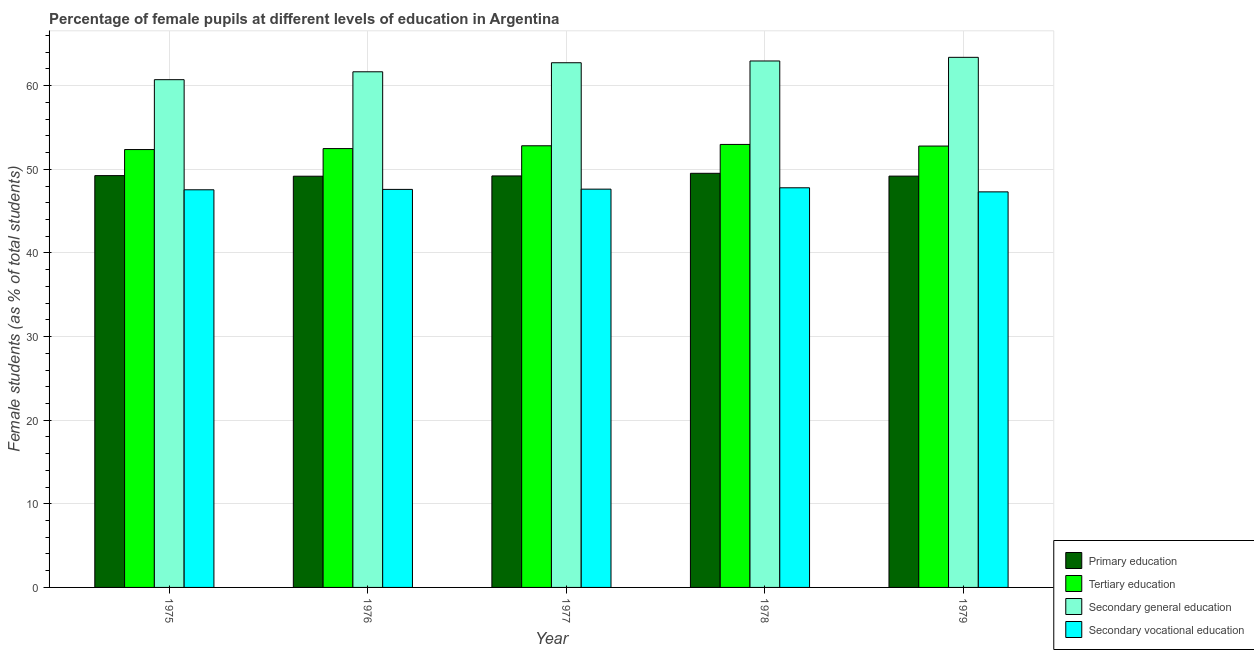Are the number of bars on each tick of the X-axis equal?
Offer a very short reply. Yes. How many bars are there on the 1st tick from the left?
Provide a succinct answer. 4. How many bars are there on the 5th tick from the right?
Ensure brevity in your answer.  4. What is the label of the 5th group of bars from the left?
Give a very brief answer. 1979. In how many cases, is the number of bars for a given year not equal to the number of legend labels?
Your response must be concise. 0. What is the percentage of female students in tertiary education in 1977?
Offer a terse response. 52.82. Across all years, what is the maximum percentage of female students in primary education?
Provide a succinct answer. 49.52. Across all years, what is the minimum percentage of female students in tertiary education?
Your answer should be very brief. 52.36. In which year was the percentage of female students in secondary vocational education maximum?
Ensure brevity in your answer.  1978. In which year was the percentage of female students in secondary vocational education minimum?
Your response must be concise. 1979. What is the total percentage of female students in secondary education in the graph?
Your answer should be compact. 311.48. What is the difference between the percentage of female students in secondary education in 1976 and that in 1978?
Give a very brief answer. -1.29. What is the difference between the percentage of female students in secondary vocational education in 1979 and the percentage of female students in primary education in 1975?
Offer a very short reply. -0.25. What is the average percentage of female students in primary education per year?
Make the answer very short. 49.27. In how many years, is the percentage of female students in primary education greater than 16 %?
Provide a short and direct response. 5. What is the ratio of the percentage of female students in primary education in 1975 to that in 1976?
Provide a short and direct response. 1. What is the difference between the highest and the second highest percentage of female students in secondary vocational education?
Provide a succinct answer. 0.16. What is the difference between the highest and the lowest percentage of female students in tertiary education?
Your answer should be compact. 0.61. In how many years, is the percentage of female students in secondary vocational education greater than the average percentage of female students in secondary vocational education taken over all years?
Give a very brief answer. 3. Is it the case that in every year, the sum of the percentage of female students in secondary education and percentage of female students in primary education is greater than the sum of percentage of female students in tertiary education and percentage of female students in secondary vocational education?
Ensure brevity in your answer.  Yes. What does the 2nd bar from the left in 1977 represents?
Provide a succinct answer. Tertiary education. What does the 1st bar from the right in 1976 represents?
Give a very brief answer. Secondary vocational education. How many bars are there?
Offer a terse response. 20. Are all the bars in the graph horizontal?
Your answer should be compact. No. How many years are there in the graph?
Offer a terse response. 5. Does the graph contain any zero values?
Offer a very short reply. No. Where does the legend appear in the graph?
Offer a terse response. Bottom right. How are the legend labels stacked?
Make the answer very short. Vertical. What is the title of the graph?
Offer a terse response. Percentage of female pupils at different levels of education in Argentina. Does "Quality of public administration" appear as one of the legend labels in the graph?
Your answer should be compact. No. What is the label or title of the Y-axis?
Keep it short and to the point. Female students (as % of total students). What is the Female students (as % of total students) in Primary education in 1975?
Offer a very short reply. 49.25. What is the Female students (as % of total students) in Tertiary education in 1975?
Offer a very short reply. 52.36. What is the Female students (as % of total students) in Secondary general education in 1975?
Your response must be concise. 60.72. What is the Female students (as % of total students) in Secondary vocational education in 1975?
Provide a short and direct response. 47.55. What is the Female students (as % of total students) of Primary education in 1976?
Your response must be concise. 49.18. What is the Female students (as % of total students) of Tertiary education in 1976?
Give a very brief answer. 52.48. What is the Female students (as % of total students) of Secondary general education in 1976?
Provide a short and direct response. 61.66. What is the Female students (as % of total students) in Secondary vocational education in 1976?
Provide a succinct answer. 47.6. What is the Female students (as % of total students) in Primary education in 1977?
Give a very brief answer. 49.21. What is the Female students (as % of total students) in Tertiary education in 1977?
Keep it short and to the point. 52.82. What is the Female students (as % of total students) of Secondary general education in 1977?
Offer a very short reply. 62.75. What is the Female students (as % of total students) in Secondary vocational education in 1977?
Make the answer very short. 47.63. What is the Female students (as % of total students) of Primary education in 1978?
Your answer should be compact. 49.52. What is the Female students (as % of total students) in Tertiary education in 1978?
Ensure brevity in your answer.  52.98. What is the Female students (as % of total students) in Secondary general education in 1978?
Your answer should be very brief. 62.96. What is the Female students (as % of total students) of Secondary vocational education in 1978?
Offer a very short reply. 47.79. What is the Female students (as % of total students) of Primary education in 1979?
Provide a short and direct response. 49.19. What is the Female students (as % of total students) of Tertiary education in 1979?
Your response must be concise. 52.78. What is the Female students (as % of total students) of Secondary general education in 1979?
Offer a very short reply. 63.39. What is the Female students (as % of total students) in Secondary vocational education in 1979?
Your answer should be compact. 47.3. Across all years, what is the maximum Female students (as % of total students) of Primary education?
Keep it short and to the point. 49.52. Across all years, what is the maximum Female students (as % of total students) in Tertiary education?
Keep it short and to the point. 52.98. Across all years, what is the maximum Female students (as % of total students) in Secondary general education?
Provide a succinct answer. 63.39. Across all years, what is the maximum Female students (as % of total students) of Secondary vocational education?
Provide a succinct answer. 47.79. Across all years, what is the minimum Female students (as % of total students) in Primary education?
Give a very brief answer. 49.18. Across all years, what is the minimum Female students (as % of total students) in Tertiary education?
Your response must be concise. 52.36. Across all years, what is the minimum Female students (as % of total students) in Secondary general education?
Your answer should be compact. 60.72. Across all years, what is the minimum Female students (as % of total students) of Secondary vocational education?
Your answer should be very brief. 47.3. What is the total Female students (as % of total students) in Primary education in the graph?
Provide a short and direct response. 246.34. What is the total Female students (as % of total students) in Tertiary education in the graph?
Ensure brevity in your answer.  263.42. What is the total Female students (as % of total students) of Secondary general education in the graph?
Provide a short and direct response. 311.48. What is the total Female students (as % of total students) of Secondary vocational education in the graph?
Make the answer very short. 237.88. What is the difference between the Female students (as % of total students) of Primary education in 1975 and that in 1976?
Offer a terse response. 0.07. What is the difference between the Female students (as % of total students) in Tertiary education in 1975 and that in 1976?
Keep it short and to the point. -0.12. What is the difference between the Female students (as % of total students) in Secondary general education in 1975 and that in 1976?
Your answer should be very brief. -0.94. What is the difference between the Female students (as % of total students) of Secondary vocational education in 1975 and that in 1976?
Make the answer very short. -0.05. What is the difference between the Female students (as % of total students) of Primary education in 1975 and that in 1977?
Ensure brevity in your answer.  0.04. What is the difference between the Female students (as % of total students) in Tertiary education in 1975 and that in 1977?
Offer a very short reply. -0.45. What is the difference between the Female students (as % of total students) in Secondary general education in 1975 and that in 1977?
Your response must be concise. -2.03. What is the difference between the Female students (as % of total students) in Secondary vocational education in 1975 and that in 1977?
Ensure brevity in your answer.  -0.08. What is the difference between the Female students (as % of total students) of Primary education in 1975 and that in 1978?
Ensure brevity in your answer.  -0.28. What is the difference between the Female students (as % of total students) of Tertiary education in 1975 and that in 1978?
Your answer should be very brief. -0.61. What is the difference between the Female students (as % of total students) in Secondary general education in 1975 and that in 1978?
Keep it short and to the point. -2.24. What is the difference between the Female students (as % of total students) in Secondary vocational education in 1975 and that in 1978?
Make the answer very short. -0.24. What is the difference between the Female students (as % of total students) in Primary education in 1975 and that in 1979?
Your answer should be compact. 0.06. What is the difference between the Female students (as % of total students) in Tertiary education in 1975 and that in 1979?
Offer a terse response. -0.42. What is the difference between the Female students (as % of total students) in Secondary general education in 1975 and that in 1979?
Offer a terse response. -2.67. What is the difference between the Female students (as % of total students) of Secondary vocational education in 1975 and that in 1979?
Your answer should be very brief. 0.25. What is the difference between the Female students (as % of total students) in Primary education in 1976 and that in 1977?
Offer a very short reply. -0.03. What is the difference between the Female students (as % of total students) of Tertiary education in 1976 and that in 1977?
Provide a succinct answer. -0.33. What is the difference between the Female students (as % of total students) in Secondary general education in 1976 and that in 1977?
Keep it short and to the point. -1.08. What is the difference between the Female students (as % of total students) in Secondary vocational education in 1976 and that in 1977?
Offer a very short reply. -0.03. What is the difference between the Female students (as % of total students) in Primary education in 1976 and that in 1978?
Your answer should be very brief. -0.35. What is the difference between the Female students (as % of total students) in Tertiary education in 1976 and that in 1978?
Provide a succinct answer. -0.5. What is the difference between the Female students (as % of total students) in Secondary general education in 1976 and that in 1978?
Your answer should be very brief. -1.29. What is the difference between the Female students (as % of total students) of Secondary vocational education in 1976 and that in 1978?
Make the answer very short. -0.19. What is the difference between the Female students (as % of total students) of Primary education in 1976 and that in 1979?
Ensure brevity in your answer.  -0.01. What is the difference between the Female students (as % of total students) in Tertiary education in 1976 and that in 1979?
Make the answer very short. -0.3. What is the difference between the Female students (as % of total students) in Secondary general education in 1976 and that in 1979?
Provide a succinct answer. -1.73. What is the difference between the Female students (as % of total students) of Secondary vocational education in 1976 and that in 1979?
Your response must be concise. 0.29. What is the difference between the Female students (as % of total students) in Primary education in 1977 and that in 1978?
Your answer should be very brief. -0.31. What is the difference between the Female students (as % of total students) of Tertiary education in 1977 and that in 1978?
Make the answer very short. -0.16. What is the difference between the Female students (as % of total students) in Secondary general education in 1977 and that in 1978?
Make the answer very short. -0.21. What is the difference between the Female students (as % of total students) in Secondary vocational education in 1977 and that in 1978?
Provide a succinct answer. -0.16. What is the difference between the Female students (as % of total students) in Primary education in 1977 and that in 1979?
Your response must be concise. 0.02. What is the difference between the Female students (as % of total students) in Tertiary education in 1977 and that in 1979?
Your response must be concise. 0.03. What is the difference between the Female students (as % of total students) of Secondary general education in 1977 and that in 1979?
Make the answer very short. -0.65. What is the difference between the Female students (as % of total students) in Secondary vocational education in 1977 and that in 1979?
Your answer should be very brief. 0.32. What is the difference between the Female students (as % of total students) of Primary education in 1978 and that in 1979?
Ensure brevity in your answer.  0.34. What is the difference between the Female students (as % of total students) of Tertiary education in 1978 and that in 1979?
Your answer should be compact. 0.19. What is the difference between the Female students (as % of total students) of Secondary general education in 1978 and that in 1979?
Keep it short and to the point. -0.44. What is the difference between the Female students (as % of total students) of Secondary vocational education in 1978 and that in 1979?
Give a very brief answer. 0.49. What is the difference between the Female students (as % of total students) in Primary education in 1975 and the Female students (as % of total students) in Tertiary education in 1976?
Keep it short and to the point. -3.23. What is the difference between the Female students (as % of total students) of Primary education in 1975 and the Female students (as % of total students) of Secondary general education in 1976?
Make the answer very short. -12.41. What is the difference between the Female students (as % of total students) in Primary education in 1975 and the Female students (as % of total students) in Secondary vocational education in 1976?
Make the answer very short. 1.65. What is the difference between the Female students (as % of total students) in Tertiary education in 1975 and the Female students (as % of total students) in Secondary general education in 1976?
Ensure brevity in your answer.  -9.3. What is the difference between the Female students (as % of total students) of Tertiary education in 1975 and the Female students (as % of total students) of Secondary vocational education in 1976?
Your response must be concise. 4.76. What is the difference between the Female students (as % of total students) in Secondary general education in 1975 and the Female students (as % of total students) in Secondary vocational education in 1976?
Provide a short and direct response. 13.12. What is the difference between the Female students (as % of total students) in Primary education in 1975 and the Female students (as % of total students) in Tertiary education in 1977?
Your response must be concise. -3.57. What is the difference between the Female students (as % of total students) in Primary education in 1975 and the Female students (as % of total students) in Secondary general education in 1977?
Your answer should be very brief. -13.5. What is the difference between the Female students (as % of total students) in Primary education in 1975 and the Female students (as % of total students) in Secondary vocational education in 1977?
Offer a very short reply. 1.62. What is the difference between the Female students (as % of total students) in Tertiary education in 1975 and the Female students (as % of total students) in Secondary general education in 1977?
Your answer should be very brief. -10.38. What is the difference between the Female students (as % of total students) in Tertiary education in 1975 and the Female students (as % of total students) in Secondary vocational education in 1977?
Make the answer very short. 4.73. What is the difference between the Female students (as % of total students) in Secondary general education in 1975 and the Female students (as % of total students) in Secondary vocational education in 1977?
Ensure brevity in your answer.  13.09. What is the difference between the Female students (as % of total students) in Primary education in 1975 and the Female students (as % of total students) in Tertiary education in 1978?
Provide a succinct answer. -3.73. What is the difference between the Female students (as % of total students) of Primary education in 1975 and the Female students (as % of total students) of Secondary general education in 1978?
Keep it short and to the point. -13.71. What is the difference between the Female students (as % of total students) in Primary education in 1975 and the Female students (as % of total students) in Secondary vocational education in 1978?
Your answer should be very brief. 1.46. What is the difference between the Female students (as % of total students) in Tertiary education in 1975 and the Female students (as % of total students) in Secondary general education in 1978?
Your answer should be compact. -10.59. What is the difference between the Female students (as % of total students) of Tertiary education in 1975 and the Female students (as % of total students) of Secondary vocational education in 1978?
Keep it short and to the point. 4.57. What is the difference between the Female students (as % of total students) of Secondary general education in 1975 and the Female students (as % of total students) of Secondary vocational education in 1978?
Your response must be concise. 12.93. What is the difference between the Female students (as % of total students) of Primary education in 1975 and the Female students (as % of total students) of Tertiary education in 1979?
Offer a terse response. -3.54. What is the difference between the Female students (as % of total students) in Primary education in 1975 and the Female students (as % of total students) in Secondary general education in 1979?
Ensure brevity in your answer.  -14.14. What is the difference between the Female students (as % of total students) in Primary education in 1975 and the Female students (as % of total students) in Secondary vocational education in 1979?
Provide a short and direct response. 1.94. What is the difference between the Female students (as % of total students) in Tertiary education in 1975 and the Female students (as % of total students) in Secondary general education in 1979?
Your answer should be compact. -11.03. What is the difference between the Female students (as % of total students) in Tertiary education in 1975 and the Female students (as % of total students) in Secondary vocational education in 1979?
Your response must be concise. 5.06. What is the difference between the Female students (as % of total students) of Secondary general education in 1975 and the Female students (as % of total students) of Secondary vocational education in 1979?
Keep it short and to the point. 13.41. What is the difference between the Female students (as % of total students) of Primary education in 1976 and the Female students (as % of total students) of Tertiary education in 1977?
Offer a terse response. -3.64. What is the difference between the Female students (as % of total students) of Primary education in 1976 and the Female students (as % of total students) of Secondary general education in 1977?
Make the answer very short. -13.57. What is the difference between the Female students (as % of total students) in Primary education in 1976 and the Female students (as % of total students) in Secondary vocational education in 1977?
Offer a terse response. 1.55. What is the difference between the Female students (as % of total students) of Tertiary education in 1976 and the Female students (as % of total students) of Secondary general education in 1977?
Ensure brevity in your answer.  -10.27. What is the difference between the Female students (as % of total students) in Tertiary education in 1976 and the Female students (as % of total students) in Secondary vocational education in 1977?
Your answer should be very brief. 4.85. What is the difference between the Female students (as % of total students) of Secondary general education in 1976 and the Female students (as % of total students) of Secondary vocational education in 1977?
Offer a very short reply. 14.03. What is the difference between the Female students (as % of total students) of Primary education in 1976 and the Female students (as % of total students) of Tertiary education in 1978?
Provide a short and direct response. -3.8. What is the difference between the Female students (as % of total students) in Primary education in 1976 and the Female students (as % of total students) in Secondary general education in 1978?
Make the answer very short. -13.78. What is the difference between the Female students (as % of total students) of Primary education in 1976 and the Female students (as % of total students) of Secondary vocational education in 1978?
Your answer should be very brief. 1.38. What is the difference between the Female students (as % of total students) of Tertiary education in 1976 and the Female students (as % of total students) of Secondary general education in 1978?
Your response must be concise. -10.48. What is the difference between the Female students (as % of total students) in Tertiary education in 1976 and the Female students (as % of total students) in Secondary vocational education in 1978?
Make the answer very short. 4.69. What is the difference between the Female students (as % of total students) in Secondary general education in 1976 and the Female students (as % of total students) in Secondary vocational education in 1978?
Ensure brevity in your answer.  13.87. What is the difference between the Female students (as % of total students) of Primary education in 1976 and the Female students (as % of total students) of Tertiary education in 1979?
Keep it short and to the point. -3.61. What is the difference between the Female students (as % of total students) in Primary education in 1976 and the Female students (as % of total students) in Secondary general education in 1979?
Make the answer very short. -14.22. What is the difference between the Female students (as % of total students) of Primary education in 1976 and the Female students (as % of total students) of Secondary vocational education in 1979?
Your answer should be compact. 1.87. What is the difference between the Female students (as % of total students) in Tertiary education in 1976 and the Female students (as % of total students) in Secondary general education in 1979?
Ensure brevity in your answer.  -10.91. What is the difference between the Female students (as % of total students) of Tertiary education in 1976 and the Female students (as % of total students) of Secondary vocational education in 1979?
Offer a very short reply. 5.18. What is the difference between the Female students (as % of total students) of Secondary general education in 1976 and the Female students (as % of total students) of Secondary vocational education in 1979?
Your answer should be very brief. 14.36. What is the difference between the Female students (as % of total students) of Primary education in 1977 and the Female students (as % of total students) of Tertiary education in 1978?
Offer a very short reply. -3.77. What is the difference between the Female students (as % of total students) in Primary education in 1977 and the Female students (as % of total students) in Secondary general education in 1978?
Offer a very short reply. -13.75. What is the difference between the Female students (as % of total students) in Primary education in 1977 and the Female students (as % of total students) in Secondary vocational education in 1978?
Offer a very short reply. 1.42. What is the difference between the Female students (as % of total students) of Tertiary education in 1977 and the Female students (as % of total students) of Secondary general education in 1978?
Your answer should be compact. -10.14. What is the difference between the Female students (as % of total students) in Tertiary education in 1977 and the Female students (as % of total students) in Secondary vocational education in 1978?
Ensure brevity in your answer.  5.02. What is the difference between the Female students (as % of total students) of Secondary general education in 1977 and the Female students (as % of total students) of Secondary vocational education in 1978?
Your answer should be very brief. 14.95. What is the difference between the Female students (as % of total students) in Primary education in 1977 and the Female students (as % of total students) in Tertiary education in 1979?
Ensure brevity in your answer.  -3.57. What is the difference between the Female students (as % of total students) in Primary education in 1977 and the Female students (as % of total students) in Secondary general education in 1979?
Your answer should be very brief. -14.18. What is the difference between the Female students (as % of total students) in Primary education in 1977 and the Female students (as % of total students) in Secondary vocational education in 1979?
Your answer should be very brief. 1.9. What is the difference between the Female students (as % of total students) of Tertiary education in 1977 and the Female students (as % of total students) of Secondary general education in 1979?
Offer a very short reply. -10.58. What is the difference between the Female students (as % of total students) of Tertiary education in 1977 and the Female students (as % of total students) of Secondary vocational education in 1979?
Offer a terse response. 5.51. What is the difference between the Female students (as % of total students) in Secondary general education in 1977 and the Female students (as % of total students) in Secondary vocational education in 1979?
Ensure brevity in your answer.  15.44. What is the difference between the Female students (as % of total students) in Primary education in 1978 and the Female students (as % of total students) in Tertiary education in 1979?
Provide a succinct answer. -3.26. What is the difference between the Female students (as % of total students) in Primary education in 1978 and the Female students (as % of total students) in Secondary general education in 1979?
Provide a short and direct response. -13.87. What is the difference between the Female students (as % of total students) of Primary education in 1978 and the Female students (as % of total students) of Secondary vocational education in 1979?
Your response must be concise. 2.22. What is the difference between the Female students (as % of total students) of Tertiary education in 1978 and the Female students (as % of total students) of Secondary general education in 1979?
Ensure brevity in your answer.  -10.42. What is the difference between the Female students (as % of total students) of Tertiary education in 1978 and the Female students (as % of total students) of Secondary vocational education in 1979?
Provide a succinct answer. 5.67. What is the difference between the Female students (as % of total students) of Secondary general education in 1978 and the Female students (as % of total students) of Secondary vocational education in 1979?
Make the answer very short. 15.65. What is the average Female students (as % of total students) of Primary education per year?
Keep it short and to the point. 49.27. What is the average Female students (as % of total students) in Tertiary education per year?
Ensure brevity in your answer.  52.68. What is the average Female students (as % of total students) of Secondary general education per year?
Offer a terse response. 62.3. What is the average Female students (as % of total students) in Secondary vocational education per year?
Give a very brief answer. 47.58. In the year 1975, what is the difference between the Female students (as % of total students) of Primary education and Female students (as % of total students) of Tertiary education?
Provide a short and direct response. -3.12. In the year 1975, what is the difference between the Female students (as % of total students) in Primary education and Female students (as % of total students) in Secondary general education?
Ensure brevity in your answer.  -11.47. In the year 1975, what is the difference between the Female students (as % of total students) of Primary education and Female students (as % of total students) of Secondary vocational education?
Make the answer very short. 1.7. In the year 1975, what is the difference between the Female students (as % of total students) in Tertiary education and Female students (as % of total students) in Secondary general education?
Make the answer very short. -8.36. In the year 1975, what is the difference between the Female students (as % of total students) in Tertiary education and Female students (as % of total students) in Secondary vocational education?
Give a very brief answer. 4.81. In the year 1975, what is the difference between the Female students (as % of total students) in Secondary general education and Female students (as % of total students) in Secondary vocational education?
Make the answer very short. 13.17. In the year 1976, what is the difference between the Female students (as % of total students) of Primary education and Female students (as % of total students) of Tertiary education?
Offer a very short reply. -3.3. In the year 1976, what is the difference between the Female students (as % of total students) of Primary education and Female students (as % of total students) of Secondary general education?
Give a very brief answer. -12.49. In the year 1976, what is the difference between the Female students (as % of total students) in Primary education and Female students (as % of total students) in Secondary vocational education?
Your answer should be compact. 1.58. In the year 1976, what is the difference between the Female students (as % of total students) in Tertiary education and Female students (as % of total students) in Secondary general education?
Provide a succinct answer. -9.18. In the year 1976, what is the difference between the Female students (as % of total students) of Tertiary education and Female students (as % of total students) of Secondary vocational education?
Make the answer very short. 4.88. In the year 1976, what is the difference between the Female students (as % of total students) of Secondary general education and Female students (as % of total students) of Secondary vocational education?
Keep it short and to the point. 14.06. In the year 1977, what is the difference between the Female students (as % of total students) in Primary education and Female students (as % of total students) in Tertiary education?
Offer a terse response. -3.61. In the year 1977, what is the difference between the Female students (as % of total students) in Primary education and Female students (as % of total students) in Secondary general education?
Offer a very short reply. -13.54. In the year 1977, what is the difference between the Female students (as % of total students) of Primary education and Female students (as % of total students) of Secondary vocational education?
Your answer should be compact. 1.58. In the year 1977, what is the difference between the Female students (as % of total students) in Tertiary education and Female students (as % of total students) in Secondary general education?
Ensure brevity in your answer.  -9.93. In the year 1977, what is the difference between the Female students (as % of total students) in Tertiary education and Female students (as % of total students) in Secondary vocational education?
Offer a terse response. 5.19. In the year 1977, what is the difference between the Female students (as % of total students) of Secondary general education and Female students (as % of total students) of Secondary vocational education?
Offer a very short reply. 15.12. In the year 1978, what is the difference between the Female students (as % of total students) in Primary education and Female students (as % of total students) in Tertiary education?
Offer a very short reply. -3.45. In the year 1978, what is the difference between the Female students (as % of total students) of Primary education and Female students (as % of total students) of Secondary general education?
Provide a short and direct response. -13.43. In the year 1978, what is the difference between the Female students (as % of total students) in Primary education and Female students (as % of total students) in Secondary vocational education?
Give a very brief answer. 1.73. In the year 1978, what is the difference between the Female students (as % of total students) of Tertiary education and Female students (as % of total students) of Secondary general education?
Offer a terse response. -9.98. In the year 1978, what is the difference between the Female students (as % of total students) in Tertiary education and Female students (as % of total students) in Secondary vocational education?
Provide a short and direct response. 5.18. In the year 1978, what is the difference between the Female students (as % of total students) in Secondary general education and Female students (as % of total students) in Secondary vocational education?
Your answer should be compact. 15.16. In the year 1979, what is the difference between the Female students (as % of total students) of Primary education and Female students (as % of total students) of Tertiary education?
Keep it short and to the point. -3.6. In the year 1979, what is the difference between the Female students (as % of total students) in Primary education and Female students (as % of total students) in Secondary general education?
Offer a very short reply. -14.21. In the year 1979, what is the difference between the Female students (as % of total students) of Primary education and Female students (as % of total students) of Secondary vocational education?
Give a very brief answer. 1.88. In the year 1979, what is the difference between the Female students (as % of total students) of Tertiary education and Female students (as % of total students) of Secondary general education?
Your response must be concise. -10.61. In the year 1979, what is the difference between the Female students (as % of total students) of Tertiary education and Female students (as % of total students) of Secondary vocational education?
Your answer should be compact. 5.48. In the year 1979, what is the difference between the Female students (as % of total students) in Secondary general education and Female students (as % of total students) in Secondary vocational education?
Ensure brevity in your answer.  16.09. What is the ratio of the Female students (as % of total students) of Secondary general education in 1975 to that in 1976?
Make the answer very short. 0.98. What is the ratio of the Female students (as % of total students) of Primary education in 1975 to that in 1977?
Make the answer very short. 1. What is the ratio of the Female students (as % of total students) in Secondary vocational education in 1975 to that in 1977?
Provide a short and direct response. 1. What is the ratio of the Female students (as % of total students) of Tertiary education in 1975 to that in 1978?
Keep it short and to the point. 0.99. What is the ratio of the Female students (as % of total students) of Secondary general education in 1975 to that in 1978?
Provide a succinct answer. 0.96. What is the ratio of the Female students (as % of total students) of Primary education in 1975 to that in 1979?
Provide a short and direct response. 1. What is the ratio of the Female students (as % of total students) in Secondary general education in 1975 to that in 1979?
Give a very brief answer. 0.96. What is the ratio of the Female students (as % of total students) of Secondary vocational education in 1975 to that in 1979?
Your answer should be compact. 1.01. What is the ratio of the Female students (as % of total students) of Primary education in 1976 to that in 1977?
Offer a very short reply. 1. What is the ratio of the Female students (as % of total students) of Secondary general education in 1976 to that in 1977?
Your answer should be compact. 0.98. What is the ratio of the Female students (as % of total students) in Secondary vocational education in 1976 to that in 1977?
Provide a succinct answer. 1. What is the ratio of the Female students (as % of total students) in Primary education in 1976 to that in 1978?
Ensure brevity in your answer.  0.99. What is the ratio of the Female students (as % of total students) of Tertiary education in 1976 to that in 1978?
Your answer should be compact. 0.99. What is the ratio of the Female students (as % of total students) in Secondary general education in 1976 to that in 1978?
Your answer should be very brief. 0.98. What is the ratio of the Female students (as % of total students) of Primary education in 1976 to that in 1979?
Your answer should be very brief. 1. What is the ratio of the Female students (as % of total students) of Tertiary education in 1976 to that in 1979?
Your response must be concise. 0.99. What is the ratio of the Female students (as % of total students) in Secondary general education in 1976 to that in 1979?
Your answer should be compact. 0.97. What is the ratio of the Female students (as % of total students) in Primary education in 1977 to that in 1978?
Your answer should be very brief. 0.99. What is the ratio of the Female students (as % of total students) in Tertiary education in 1977 to that in 1978?
Keep it short and to the point. 1. What is the ratio of the Female students (as % of total students) in Primary education in 1977 to that in 1979?
Your answer should be very brief. 1. What is the ratio of the Female students (as % of total students) in Secondary general education in 1977 to that in 1979?
Keep it short and to the point. 0.99. What is the ratio of the Female students (as % of total students) in Primary education in 1978 to that in 1979?
Keep it short and to the point. 1.01. What is the ratio of the Female students (as % of total students) in Tertiary education in 1978 to that in 1979?
Keep it short and to the point. 1. What is the ratio of the Female students (as % of total students) in Secondary general education in 1978 to that in 1979?
Your answer should be compact. 0.99. What is the ratio of the Female students (as % of total students) of Secondary vocational education in 1978 to that in 1979?
Ensure brevity in your answer.  1.01. What is the difference between the highest and the second highest Female students (as % of total students) of Primary education?
Make the answer very short. 0.28. What is the difference between the highest and the second highest Female students (as % of total students) in Tertiary education?
Offer a terse response. 0.16. What is the difference between the highest and the second highest Female students (as % of total students) in Secondary general education?
Provide a short and direct response. 0.44. What is the difference between the highest and the second highest Female students (as % of total students) in Secondary vocational education?
Ensure brevity in your answer.  0.16. What is the difference between the highest and the lowest Female students (as % of total students) of Primary education?
Your answer should be compact. 0.35. What is the difference between the highest and the lowest Female students (as % of total students) of Tertiary education?
Your answer should be compact. 0.61. What is the difference between the highest and the lowest Female students (as % of total students) in Secondary general education?
Ensure brevity in your answer.  2.67. What is the difference between the highest and the lowest Female students (as % of total students) in Secondary vocational education?
Provide a succinct answer. 0.49. 